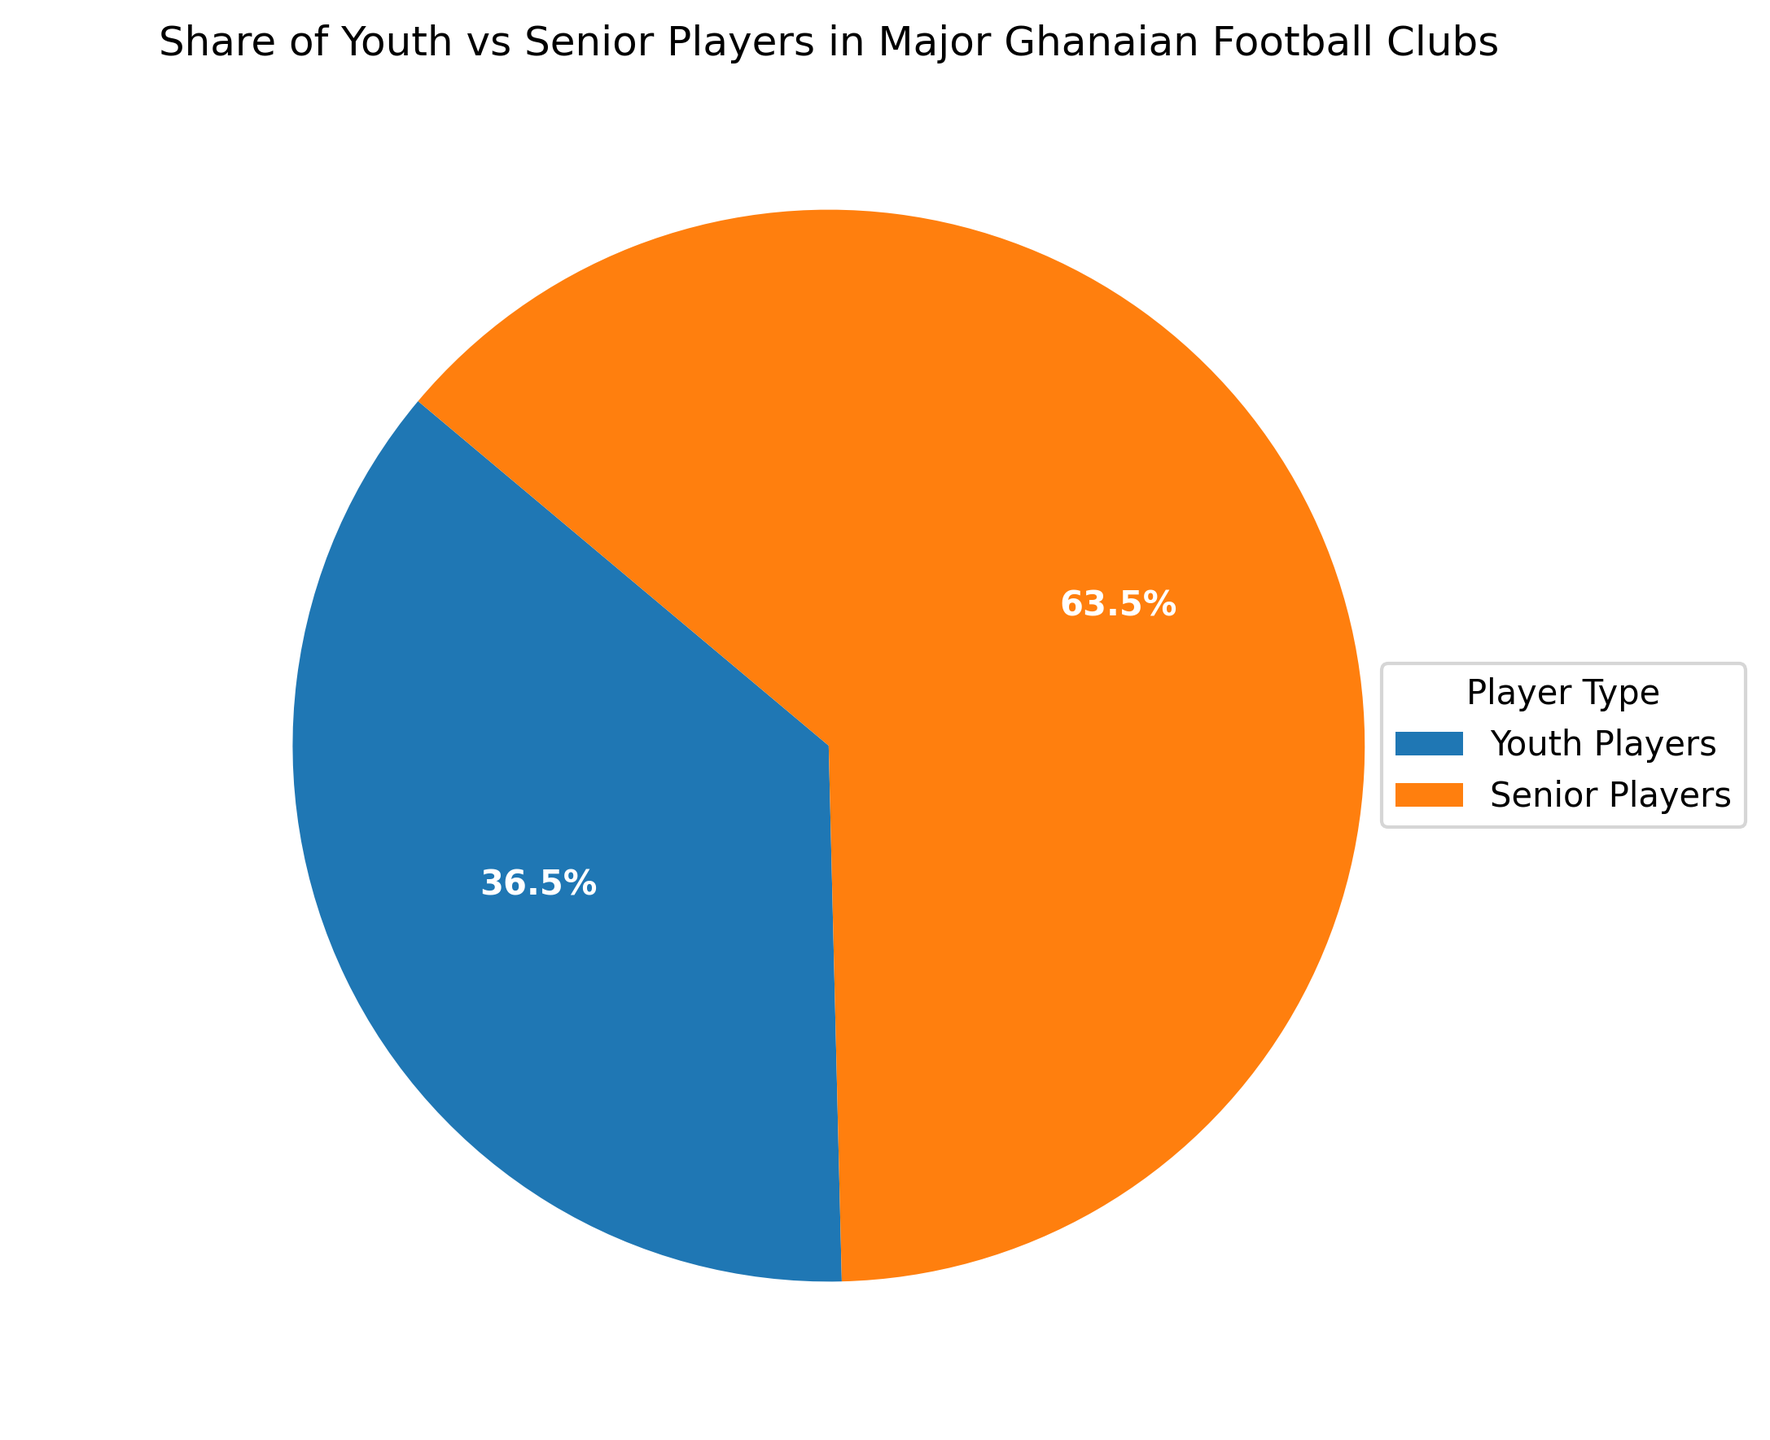What is the total percentage of senior players in the major Ghanaian football clubs? From the pie chart, we see that the portion for senior players is 70.8%. This value is derived directly from the chart's labeled sections.
Answer: 70.8% What is the difference in percentage between youth and senior players? The pie chart shows that youth players are 29.2% and senior players are 70.8%. The difference is 70.8% - 29.2% = 41.6%.
Answer: 41.6% Do youth players make up more than a quarter of the total players? The pie chart shows that youth players comprise 29.2% of the total. Since 29.2% is more than a quarter (25%), the answer is yes.
Answer: Yes Which player type has the larger share? The pie chart visually indicates that the segment for senior players is larger than the segment for youth players.
Answer: Senior Players What is the total number of players represented in the pie chart? The data table provides the number of youth and senior players for each club. Adding these: 15+25+12+28+18+22+10+30+13+27+14+26+20+20+17+23+11+29+16+24 = 450 players.
Answer: 450 What is the percentage share of youth players, rounded to the nearest whole number? The percentage share of youth players is 29.2%. Rounded to the nearest whole number, this is 29%.
Answer: 29% How does the pie chart visually distinguish between youth and senior players? The pie chart uses different colors to distinguish between youth and senior players. Youth players are depicted with a segment in one color, and senior players with another segment in a different color.
Answer: Different colors Are senior players more than twice the number of youth players? From the pie chart, we note that senior players are 70.8%, and youth players are 29.2%. Since 70.8% is more than twice 29.2%, the answer is yes.
Answer: Yes What color represents the youth players in the pie chart? The visual aspect of the pie chart shows the youth players in blue and senior players in orange.
Answer: Blue 